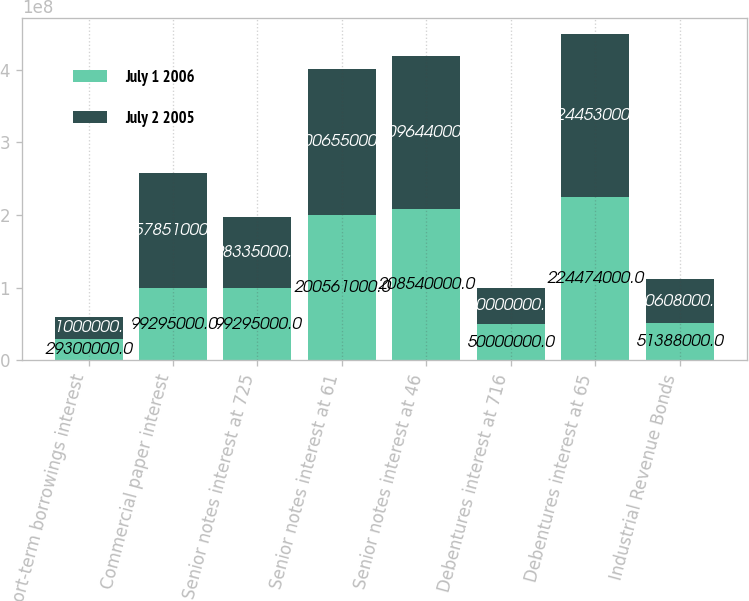<chart> <loc_0><loc_0><loc_500><loc_500><stacked_bar_chart><ecel><fcel>Short-term borrowings interest<fcel>Commercial paper interest<fcel>Senior notes interest at 725<fcel>Senior notes interest at 61<fcel>Senior notes interest at 46<fcel>Debentures interest at 716<fcel>Debentures interest at 65<fcel>Industrial Revenue Bonds<nl><fcel>July 1 2006<fcel>2.93e+07<fcel>9.9295e+07<fcel>9.9295e+07<fcel>2.00561e+08<fcel>2.0854e+08<fcel>5e+07<fcel>2.24474e+08<fcel>5.1388e+07<nl><fcel>July 2 2005<fcel>3.1e+07<fcel>1.57851e+08<fcel>9.8335e+07<fcel>2.00655e+08<fcel>2.09644e+08<fcel>5e+07<fcel>2.24453e+08<fcel>6.0608e+07<nl></chart> 